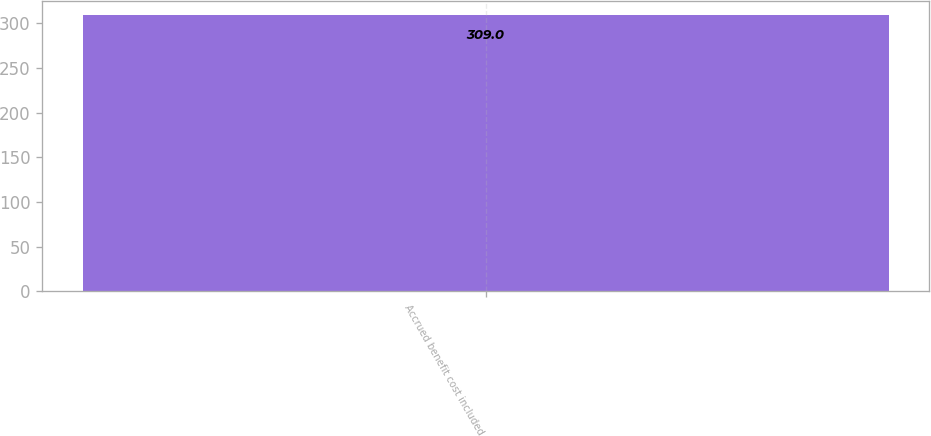Convert chart. <chart><loc_0><loc_0><loc_500><loc_500><bar_chart><fcel>Accrued benefit cost included<nl><fcel>309<nl></chart> 